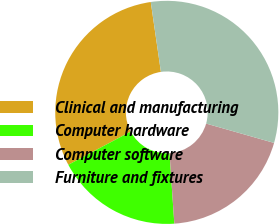Convert chart to OTSL. <chart><loc_0><loc_0><loc_500><loc_500><pie_chart><fcel>Clinical and manufacturing<fcel>Computer hardware<fcel>Computer software<fcel>Furniture and fixtures<nl><fcel>30.49%<fcel>18.29%<fcel>19.51%<fcel>31.71%<nl></chart> 